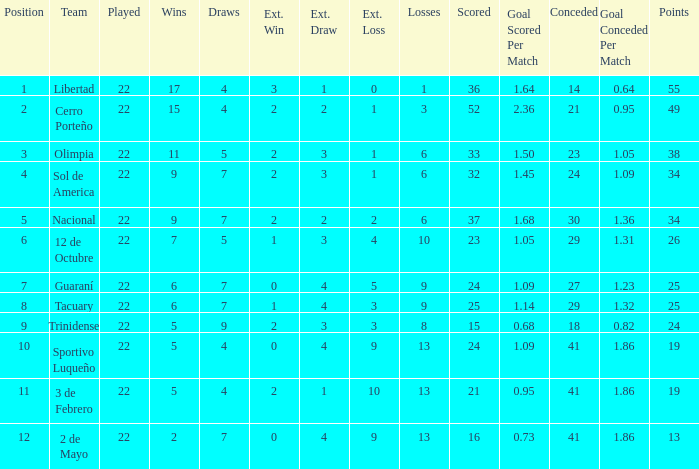What is the number of draws for the team with more than 8 losses and 13 points? 7.0. 